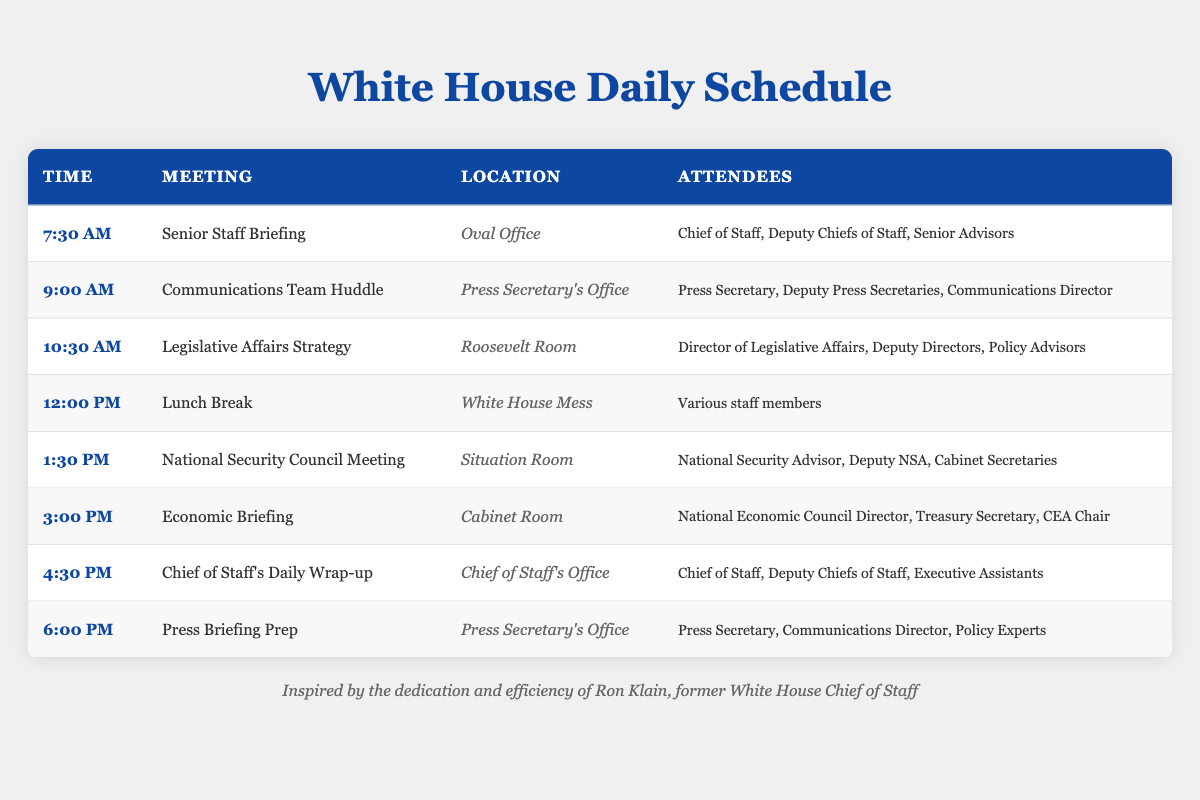What time does the Senior Staff Briefing begin? The table lists the meeting times, and under the "Time" column, the Senior Staff Briefing is scheduled for 7:30 AM.
Answer: 7:30 AM How many meetings are held in the Oval Office? From the table, the only meeting listed in the Oval Office is the Senior Staff Briefing. As there is only one entry for that location, the answer is one meeting.
Answer: 1 What is the location of the Economic Briefing? Looking at the "Location" column, the Economic Briefing takes place in the Cabinet Room.
Answer: Cabinet Room Are all attendees for the National Security Council Meeting from the National Security team? The attendees listed for the National Security Council Meeting include the National Security Advisor, Deputy NSA, and Cabinet Secretaries. Since the Cabinet Secretaries can come from various departments, not all attendees are solely from the National Security team.
Answer: No What is the time interval between the Legislative Affairs Strategy and National Security Council Meeting? The Legislative Affairs Strategy meeting is at 10:30 AM, and the National Security Council Meeting starts at 1:30 PM. The time difference is 3 hours.
Answer: 3 hours How many different locations are used for meetings today? The locations listed are Oval Office, Press Secretary's Office, Roosevelt Room, White House Mess, Situation Room, Cabinet Room, and Chief of Staff's Office, totaling seven unique locations used for meetings.
Answer: 7 What are the three attendees of the Press Briefing Prep meeting? The attendees for the Press Briefing Prep include the Press Secretary, Communications Director, and Policy Experts, as stated in the attendees column.
Answer: Press Secretary, Communications Director, Policy Experts Which meeting has the latest start time and what is the location? The last meeting on the schedule is the Press Briefing Prep at 6:00 PM, held in the Press Secretary's Office, making it both the latest meeting and location.
Answer: Press Secretary's Office How many meetings have a lunch or break scheduled? The only designated lunch break in the schedule occurs at 12:00 PM, meaning there is one meeting specifically set for a break.
Answer: 1 